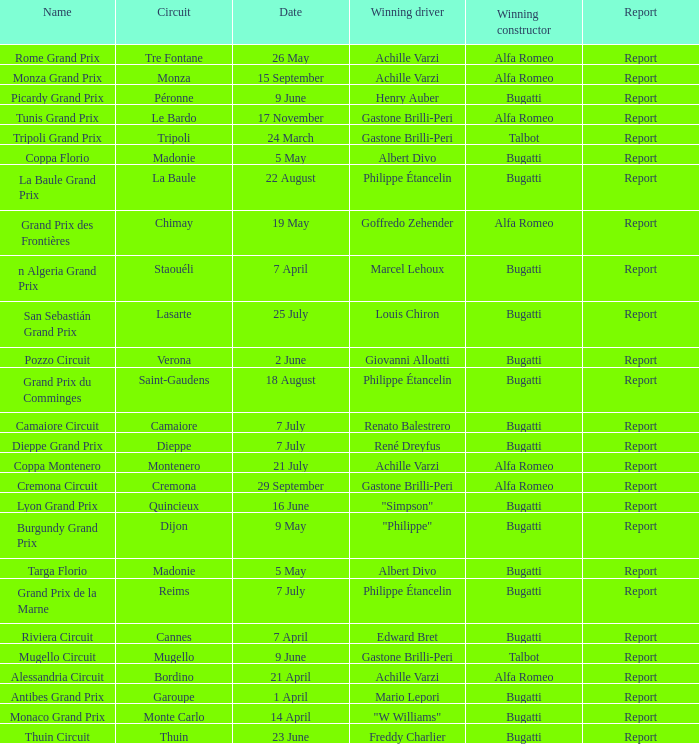What Date has a Name of thuin circuit? 23 June. Help me parse the entirety of this table. {'header': ['Name', 'Circuit', 'Date', 'Winning driver', 'Winning constructor', 'Report'], 'rows': [['Rome Grand Prix', 'Tre Fontane', '26 May', 'Achille Varzi', 'Alfa Romeo', 'Report'], ['Monza Grand Prix', 'Monza', '15 September', 'Achille Varzi', 'Alfa Romeo', 'Report'], ['Picardy Grand Prix', 'Péronne', '9 June', 'Henry Auber', 'Bugatti', 'Report'], ['Tunis Grand Prix', 'Le Bardo', '17 November', 'Gastone Brilli-Peri', 'Alfa Romeo', 'Report'], ['Tripoli Grand Prix', 'Tripoli', '24 March', 'Gastone Brilli-Peri', 'Talbot', 'Report'], ['Coppa Florio', 'Madonie', '5 May', 'Albert Divo', 'Bugatti', 'Report'], ['La Baule Grand Prix', 'La Baule', '22 August', 'Philippe Étancelin', 'Bugatti', 'Report'], ['Grand Prix des Frontières', 'Chimay', '19 May', 'Goffredo Zehender', 'Alfa Romeo', 'Report'], ['n Algeria Grand Prix', 'Staouéli', '7 April', 'Marcel Lehoux', 'Bugatti', 'Report'], ['San Sebastián Grand Prix', 'Lasarte', '25 July', 'Louis Chiron', 'Bugatti', 'Report'], ['Pozzo Circuit', 'Verona', '2 June', 'Giovanni Alloatti', 'Bugatti', 'Report'], ['Grand Prix du Comminges', 'Saint-Gaudens', '18 August', 'Philippe Étancelin', 'Bugatti', 'Report'], ['Camaiore Circuit', 'Camaiore', '7 July', 'Renato Balestrero', 'Bugatti', 'Report'], ['Dieppe Grand Prix', 'Dieppe', '7 July', 'René Dreyfus', 'Bugatti', 'Report'], ['Coppa Montenero', 'Montenero', '21 July', 'Achille Varzi', 'Alfa Romeo', 'Report'], ['Cremona Circuit', 'Cremona', '29 September', 'Gastone Brilli-Peri', 'Alfa Romeo', 'Report'], ['Lyon Grand Prix', 'Quincieux', '16 June', '"Simpson"', 'Bugatti', 'Report'], ['Burgundy Grand Prix', 'Dijon', '9 May', '"Philippe"', 'Bugatti', 'Report'], ['Targa Florio', 'Madonie', '5 May', 'Albert Divo', 'Bugatti', 'Report'], ['Grand Prix de la Marne', 'Reims', '7 July', 'Philippe Étancelin', 'Bugatti', 'Report'], ['Riviera Circuit', 'Cannes', '7 April', 'Edward Bret', 'Bugatti', 'Report'], ['Mugello Circuit', 'Mugello', '9 June', 'Gastone Brilli-Peri', 'Talbot', 'Report'], ['Alessandria Circuit', 'Bordino', '21 April', 'Achille Varzi', 'Alfa Romeo', 'Report'], ['Antibes Grand Prix', 'Garoupe', '1 April', 'Mario Lepori', 'Bugatti', 'Report'], ['Monaco Grand Prix', 'Monte Carlo', '14 April', '"W Williams"', 'Bugatti', 'Report'], ['Thuin Circuit', 'Thuin', '23 June', 'Freddy Charlier', 'Bugatti', 'Report']]} 